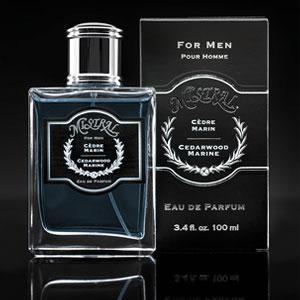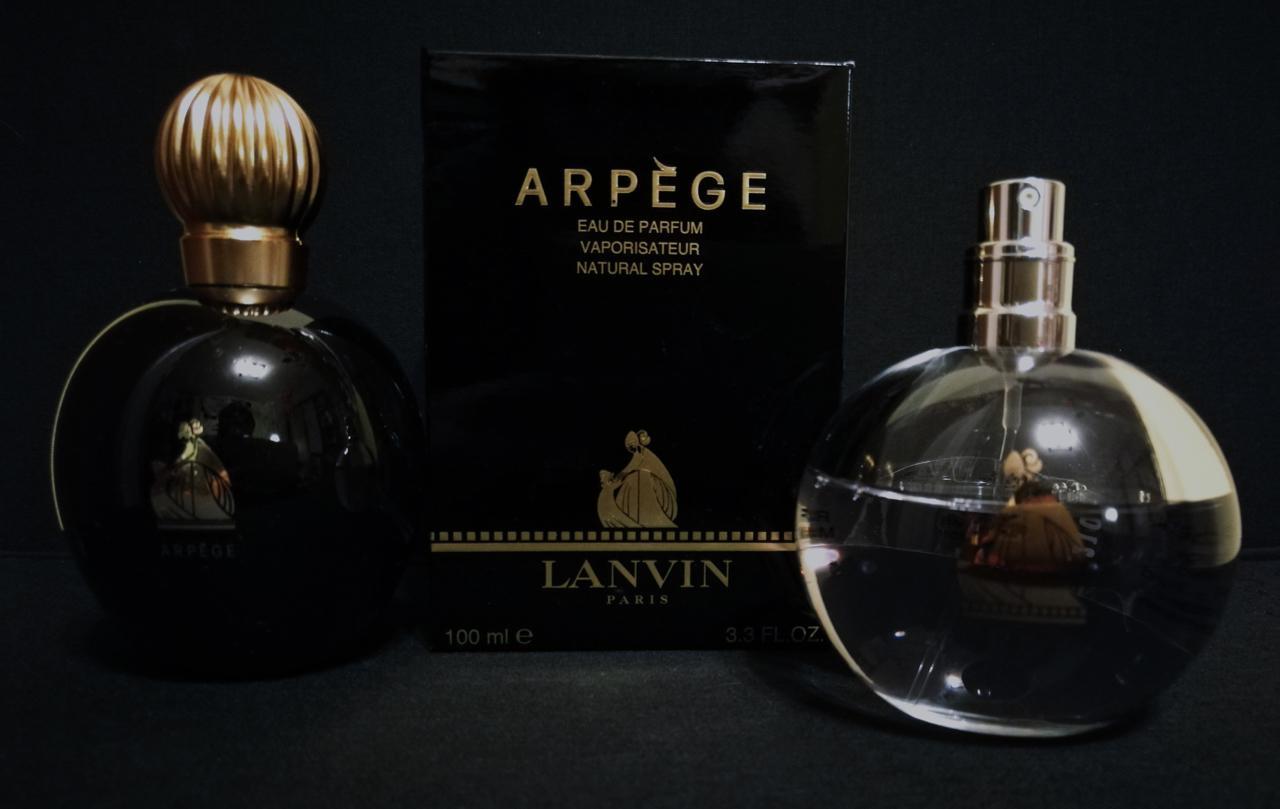The first image is the image on the left, the second image is the image on the right. Assess this claim about the two images: "There are more than two perfume bottles.". Correct or not? Answer yes or no. Yes. The first image is the image on the left, the second image is the image on the right. For the images displayed, is the sentence "An image includes a fragrance bottle with a rounded base ad round cap." factually correct? Answer yes or no. Yes. 